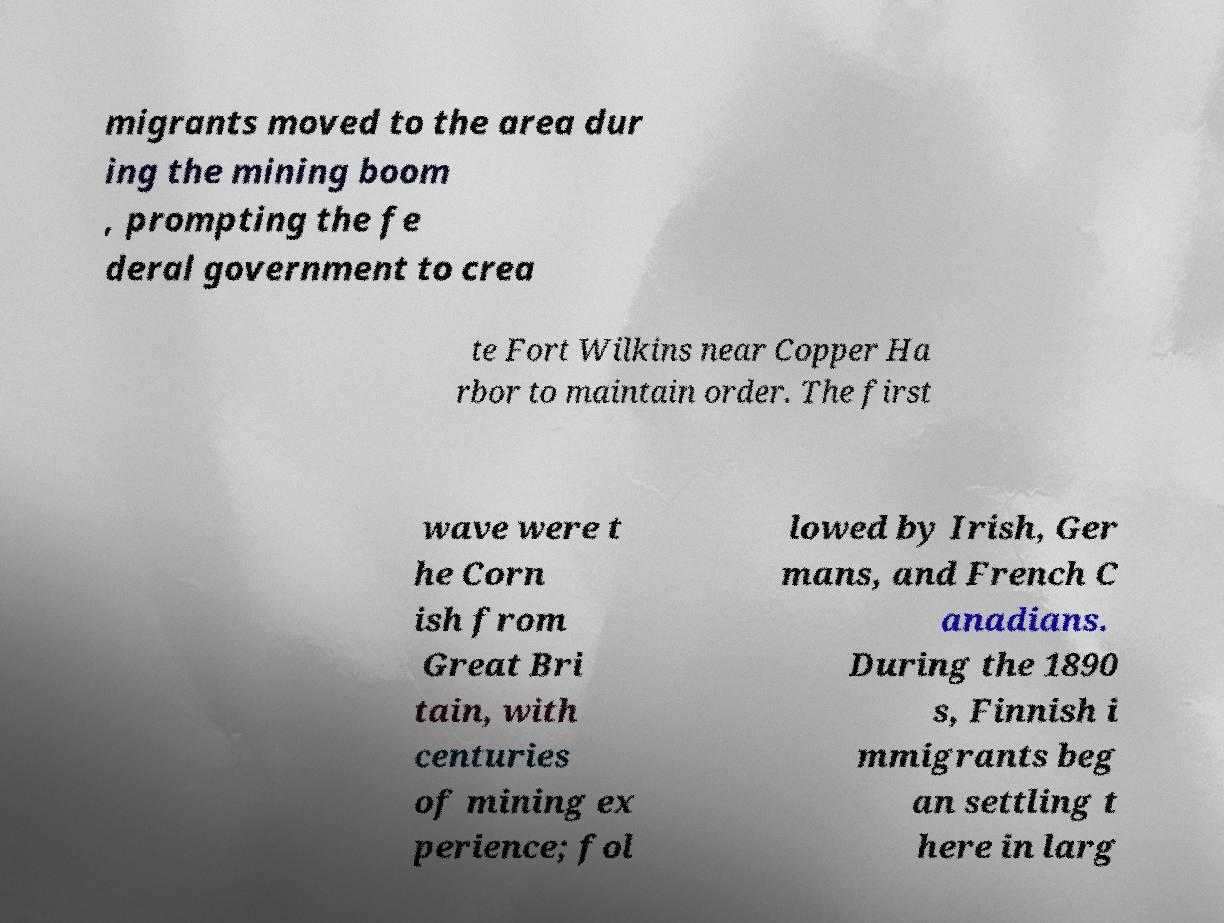Can you accurately transcribe the text from the provided image for me? migrants moved to the area dur ing the mining boom , prompting the fe deral government to crea te Fort Wilkins near Copper Ha rbor to maintain order. The first wave were t he Corn ish from Great Bri tain, with centuries of mining ex perience; fol lowed by Irish, Ger mans, and French C anadians. During the 1890 s, Finnish i mmigrants beg an settling t here in larg 